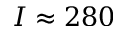Convert formula to latex. <formula><loc_0><loc_0><loc_500><loc_500>I \approx 2 8 0</formula> 